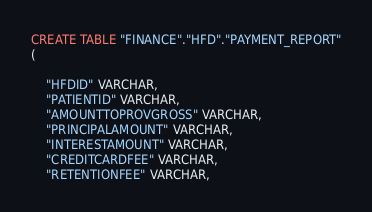<code> <loc_0><loc_0><loc_500><loc_500><_SQL_>CREATE TABLE "FINANCE"."HFD"."PAYMENT_REPORT"
(

    "HFDID" VARCHAR,
    "PATIENTID" VARCHAR,
    "AMOUNTTOPROVGROSS" VARCHAR,
    "PRINCIPALAMOUNT" VARCHAR,
    "INTERESTAMOUNT" VARCHAR,
    "CREDITCARDFEE" VARCHAR,
    "RETENTIONFEE" VARCHAR,</code> 